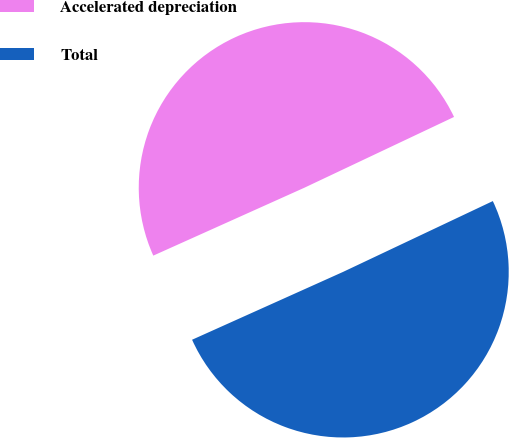<chart> <loc_0><loc_0><loc_500><loc_500><pie_chart><fcel>Accelerated depreciation<fcel>Total<nl><fcel>49.69%<fcel>50.31%<nl></chart> 